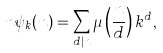<formula> <loc_0><loc_0><loc_500><loc_500>n \psi _ { k } ( n ) = \sum _ { d | n } \mu \left ( \frac { n } { d } \right ) k ^ { d } ,</formula> 